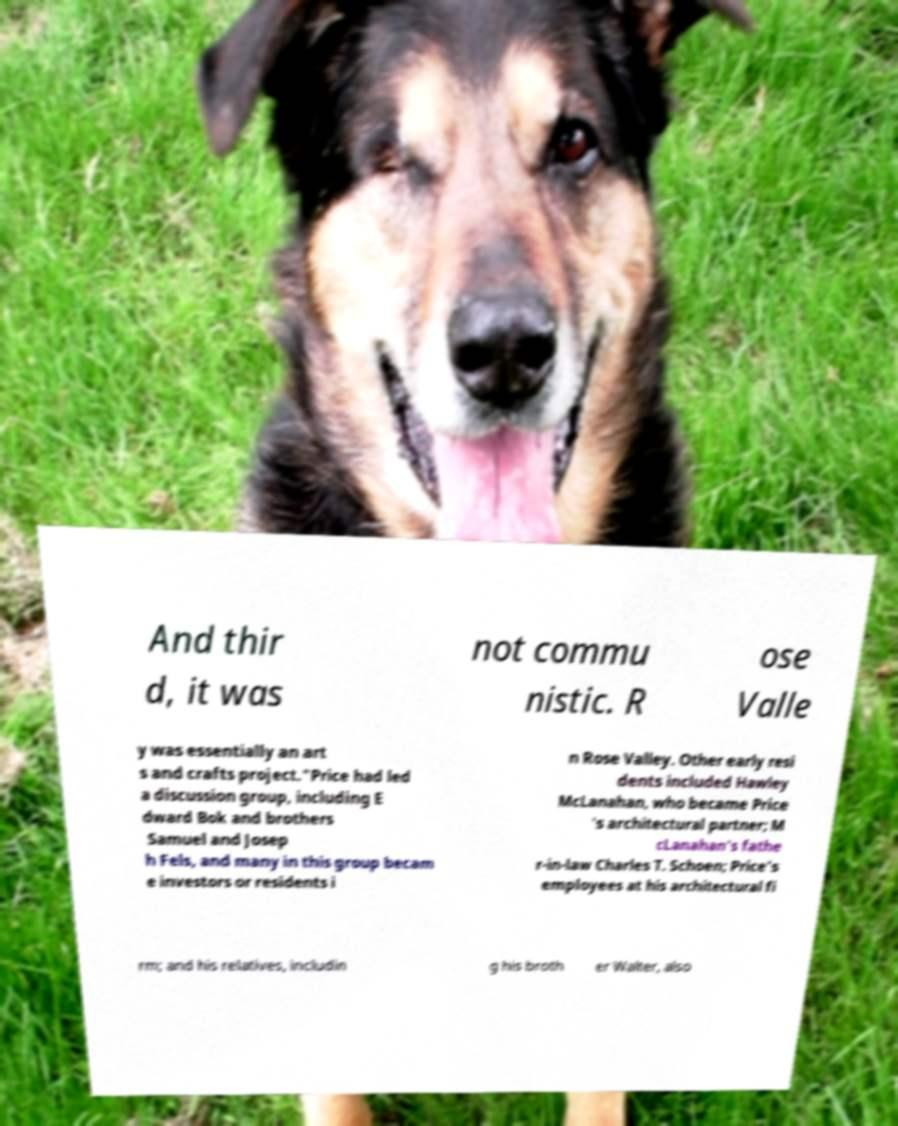Could you extract and type out the text from this image? And thir d, it was not commu nistic. R ose Valle y was essentially an art s and crafts project."Price had led a discussion group, including E dward Bok and brothers Samuel and Josep h Fels, and many in this group becam e investors or residents i n Rose Valley. Other early resi dents included Hawley McLanahan, who became Price 's architectural partner; M cLanahan's fathe r-in-law Charles T. Schoen; Price's employees at his architectural fi rm; and his relatives, includin g his broth er Walter, also 